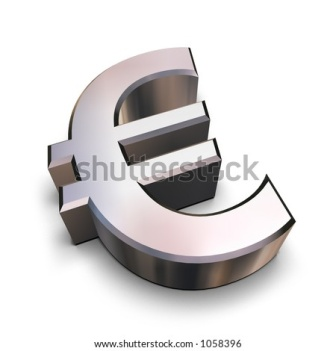If this symbol was brought to life, how would it interact with its environment? Imagine the Euro symbol coming to life, gracefully sliding off its background and exploring its surroundings. Its metallic surface gleams under different lighting, changing shades as it moves. It might interact with other symbols or objects, engaging in a magnetic dance as it represents the strength and unity of European economies. The shadow it casts would shift dynamically, creating an interplay of light and form that symbolizes the fluidity of international finance. What if the Euro symbol went on an adventure across Europe? Embarking on a grand tour, the animated Euro symbol travels across the diverse landscapes of Europe. Starting in the bustling streets of Frankfurt, it dances through financial districts, symbolizing growth and prosperity. In Paris, it navigates historic landmarks like the Eiffel Tower, mingling with elements of art and culture. As it glides through ancient ruins in Greece, it connects with the rich history of civilization. In the Scandinavian fjords, it reflects off pristine waters, embodying natural beauty and environmental sustainability. Each step of its journey weaves a narrative of unity, diversity, and shared ambitions of the European people. 